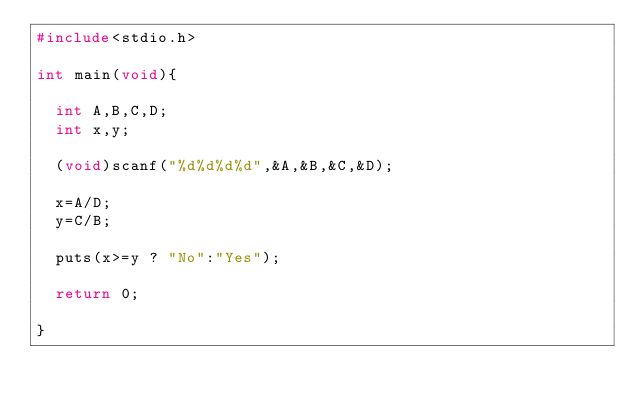<code> <loc_0><loc_0><loc_500><loc_500><_C_>#include<stdio.h>
 
int main(void){
  
  int A,B,C,D;
  int x,y;
  
  (void)scanf("%d%d%d%d",&A,&B,&C,&D);
  
  x=A/D;
  y=C/B;
  
  puts(x>=y ? "No":"Yes");
  
  return 0;
  
}
</code> 